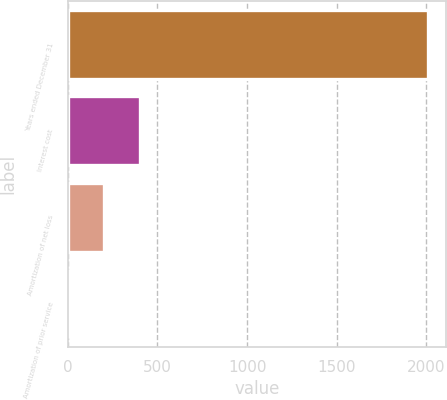Convert chart to OTSL. <chart><loc_0><loc_0><loc_500><loc_500><bar_chart><fcel>Years ended December 31<fcel>Interest cost<fcel>Amortization of net loss<fcel>Amortization of prior service<nl><fcel>2008<fcel>404<fcel>203.5<fcel>3<nl></chart> 